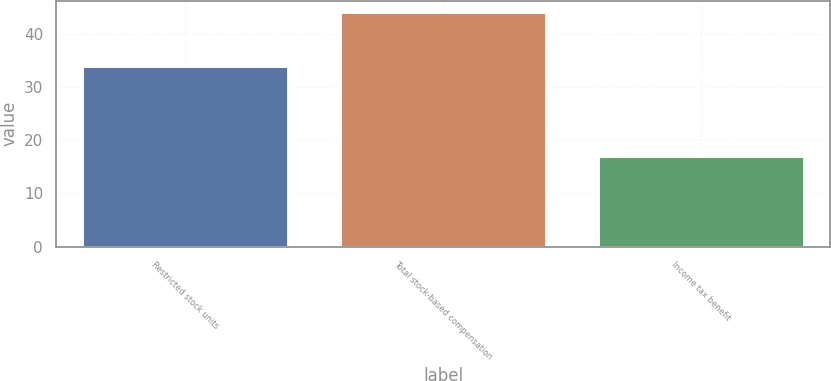<chart> <loc_0><loc_0><loc_500><loc_500><bar_chart><fcel>Restricted stock units<fcel>Total stock-based compensation<fcel>Income tax benefit<nl><fcel>34<fcel>44<fcel>17<nl></chart> 